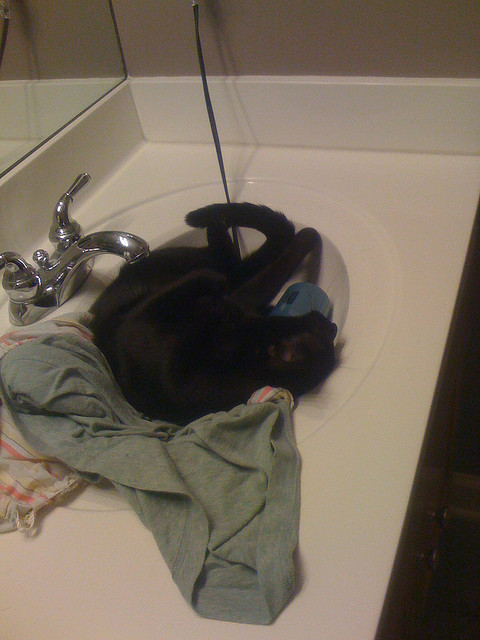What other objects are visible in the image? In the image, we can see a shiny, silver faucet mounted on the sink. There is a stack of towels and clothes next to the cat. The sink is part of a white countertop, which reflects part of the background due to its glossy finish. Why do you think the cat chose this spot to rest? Cats often seek out places that offer warmth and a sense of security. The sink, being a small, enclosed space, might provide the cat with a sense of coziness and safety. Additionally, the clothes and towels in the sink offer a soft and warm spot, making it an appealing resting place for the cat. 